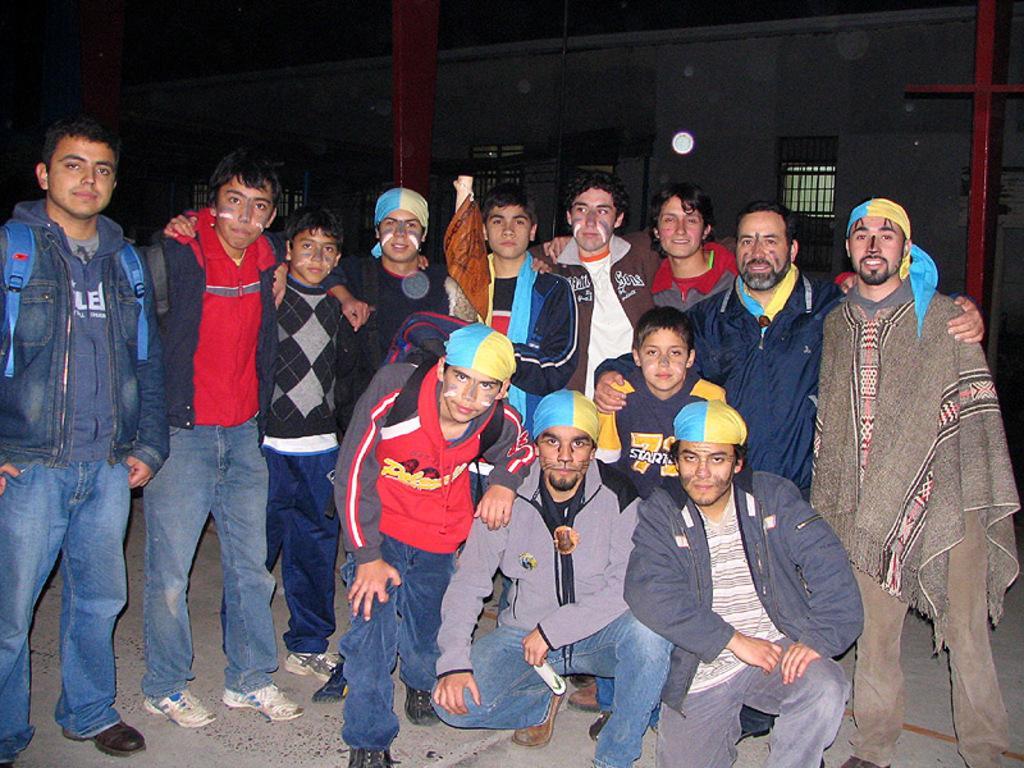Describe this image in one or two sentences. In this picture there is a man who is wearing red jacket, grey hoodie, cap, jeans and shoe. Beside him we can see another man who is in squat position. He is wearing grey jeans and shoe, beside him there is a boy who is wearing blue t-shirt. Beside him we can see another man who is wearing jacket, t-shirt and shoe. In the bank we can see the group of persons were standing in the line. In the background we can see the building and light. On the right there is a red steel pipe. At the top we can see the darkness. 